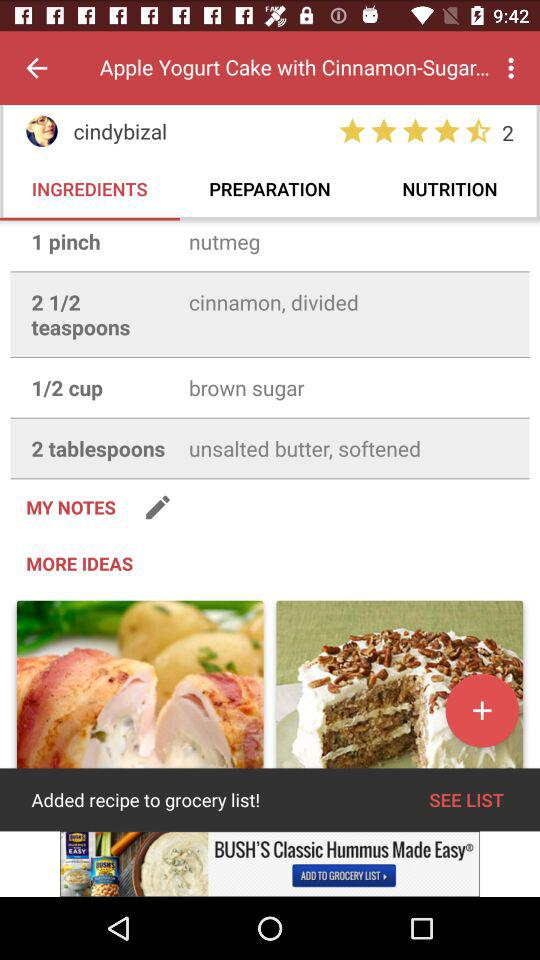What is the rating? The rating is 4.5 stars. 